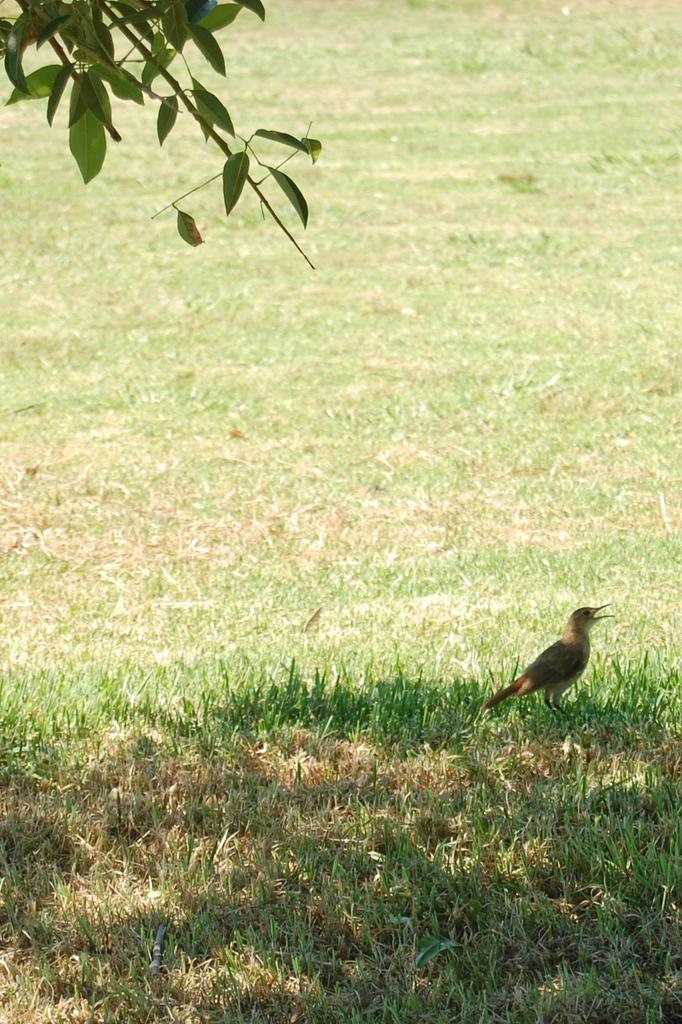What type of animal can be seen in the image? There is a bird in the image. What type of vegetation is at the bottom of the image? There is grass at the bottom of the image. Where is the tree located in the image? The tree is on the left side of the image. What type of structure can be seen near the coast in the image? There is no coast or structure present in the image; it features a bird, grass, and a tree. 